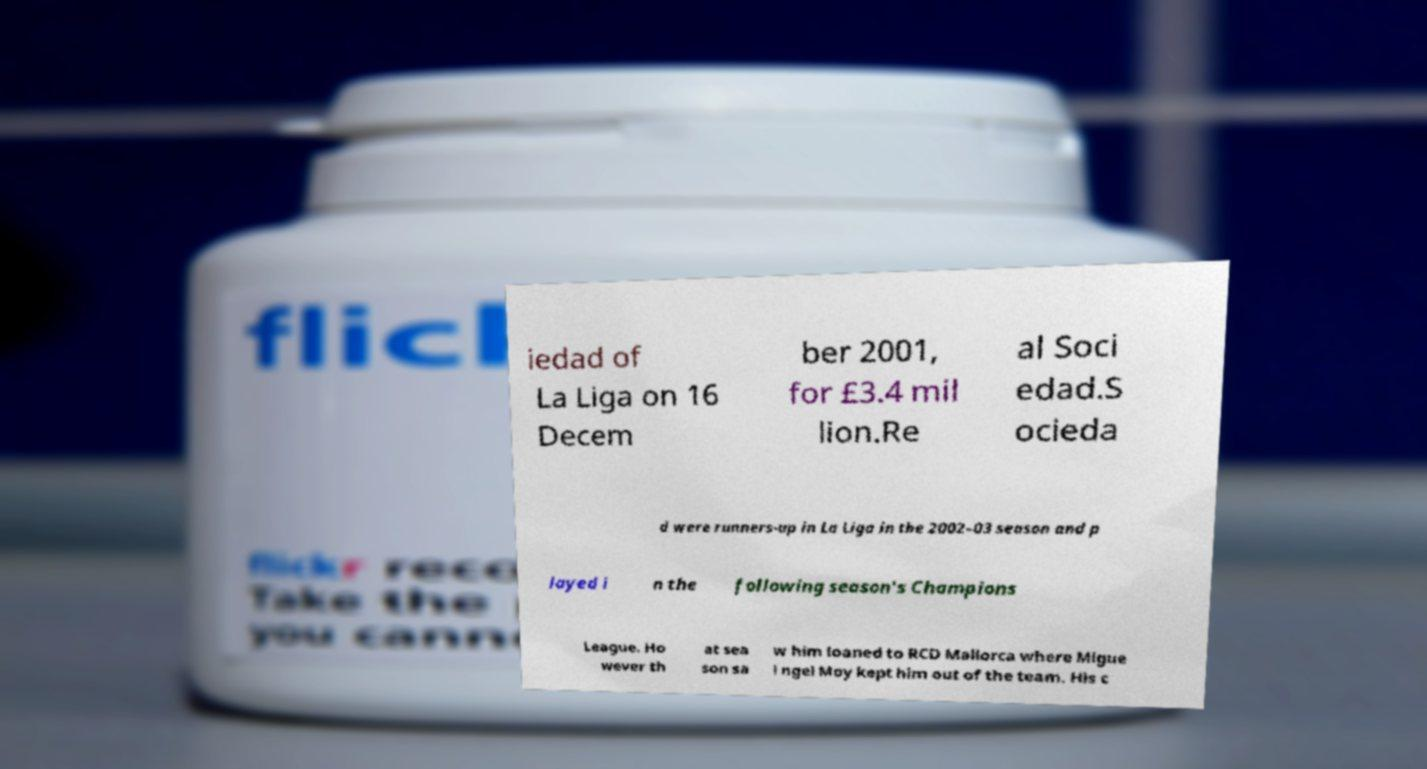For documentation purposes, I need the text within this image transcribed. Could you provide that? iedad of La Liga on 16 Decem ber 2001, for £3.4 mil lion.Re al Soci edad.S ocieda d were runners-up in La Liga in the 2002–03 season and p layed i n the following season's Champions League. Ho wever th at sea son sa w him loaned to RCD Mallorca where Migue l ngel Moy kept him out of the team. His c 